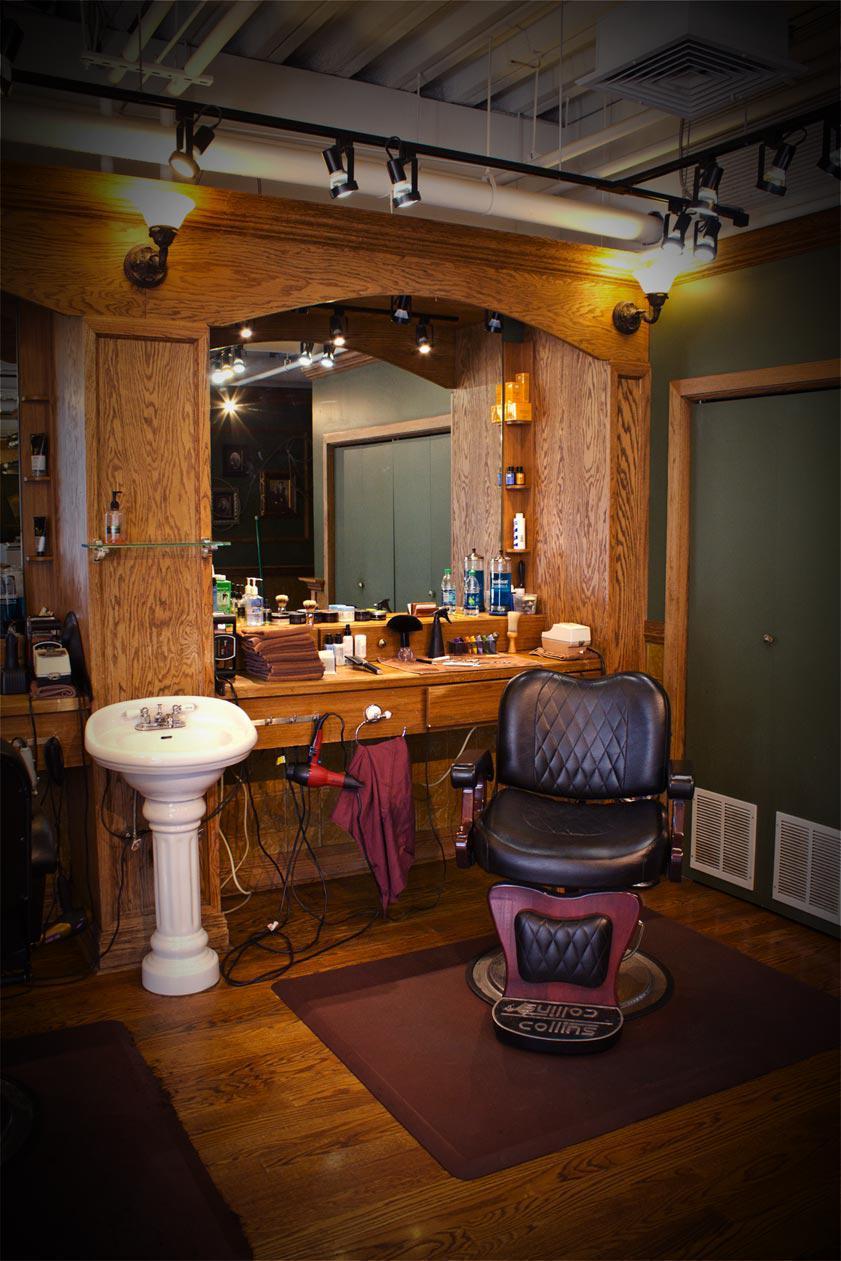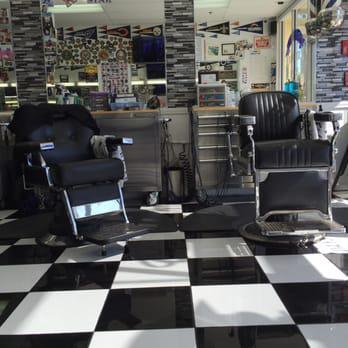The first image is the image on the left, the second image is the image on the right. For the images displayed, is the sentence "There is a total of four barber chairs." factually correct? Answer yes or no. No. The first image is the image on the left, the second image is the image on the right. Examine the images to the left and right. Is the description "Two black, forward facing, barber chairs are in one of the images." accurate? Answer yes or no. Yes. 